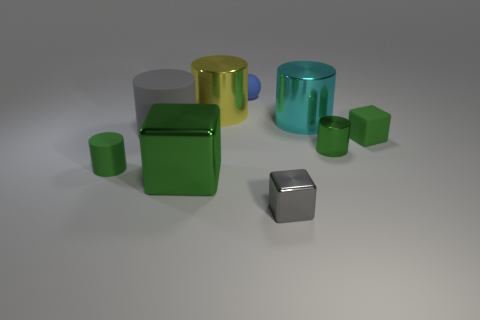What size is the metallic block that is the same color as the tiny metal cylinder? The metallic block that shares the same green color as the tiny metal cylinder is of medium size, compared to the other objects in the image. It features a cube-like shape and displays a shiny, reflective surface similar to its smaller cylindrical counterpart. 